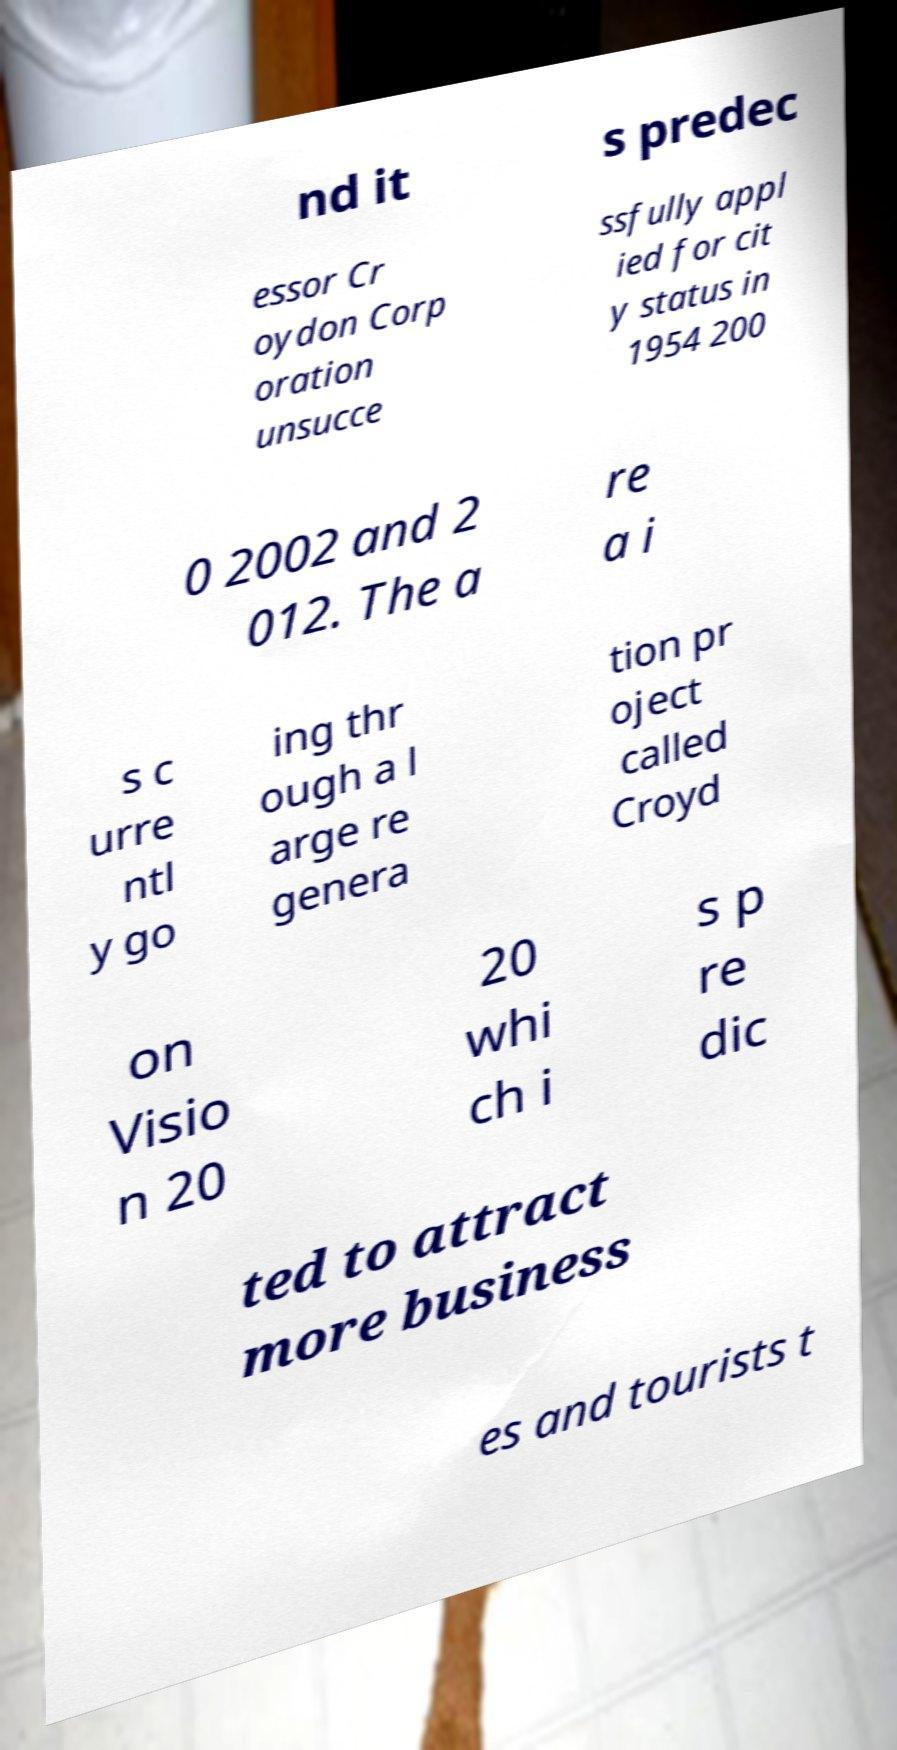Please identify and transcribe the text found in this image. nd it s predec essor Cr oydon Corp oration unsucce ssfully appl ied for cit y status in 1954 200 0 2002 and 2 012. The a re a i s c urre ntl y go ing thr ough a l arge re genera tion pr oject called Croyd on Visio n 20 20 whi ch i s p re dic ted to attract more business es and tourists t 